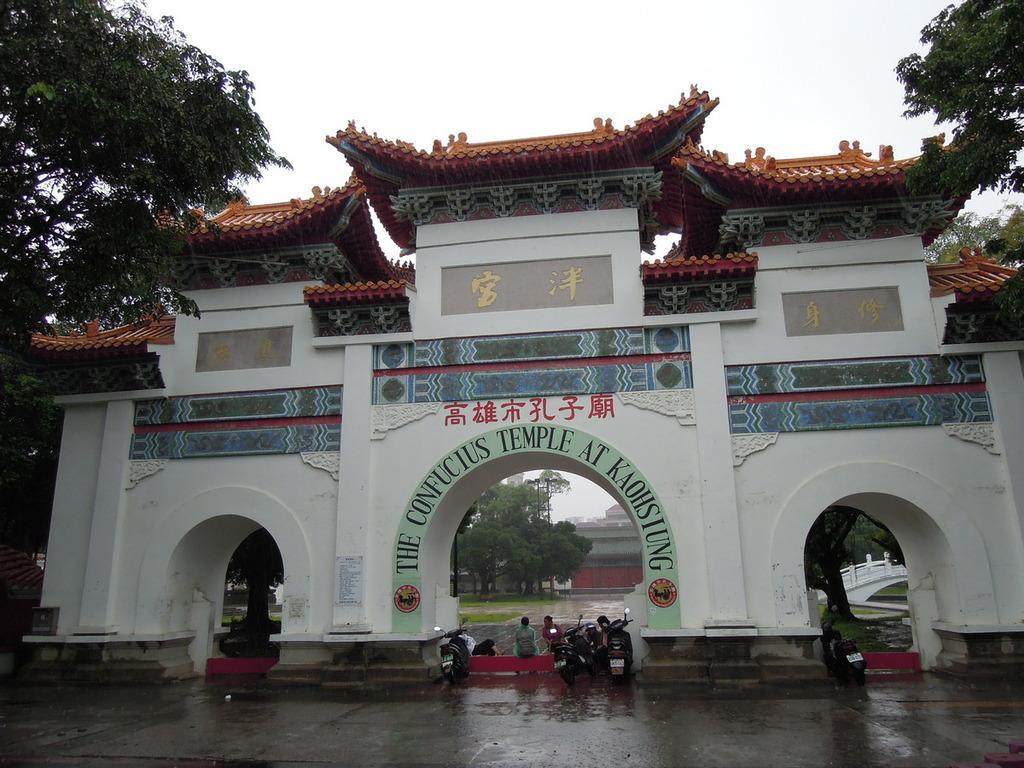Could you give a brief overview of what you see in this image? In this image we can able to see a arch, and there are four bikes parked here, and we can able to see persons sitting here, there are trees over here, we can able to see some more trees, here and we can able to see temple, we can able to sky here, and there is a box over here. 